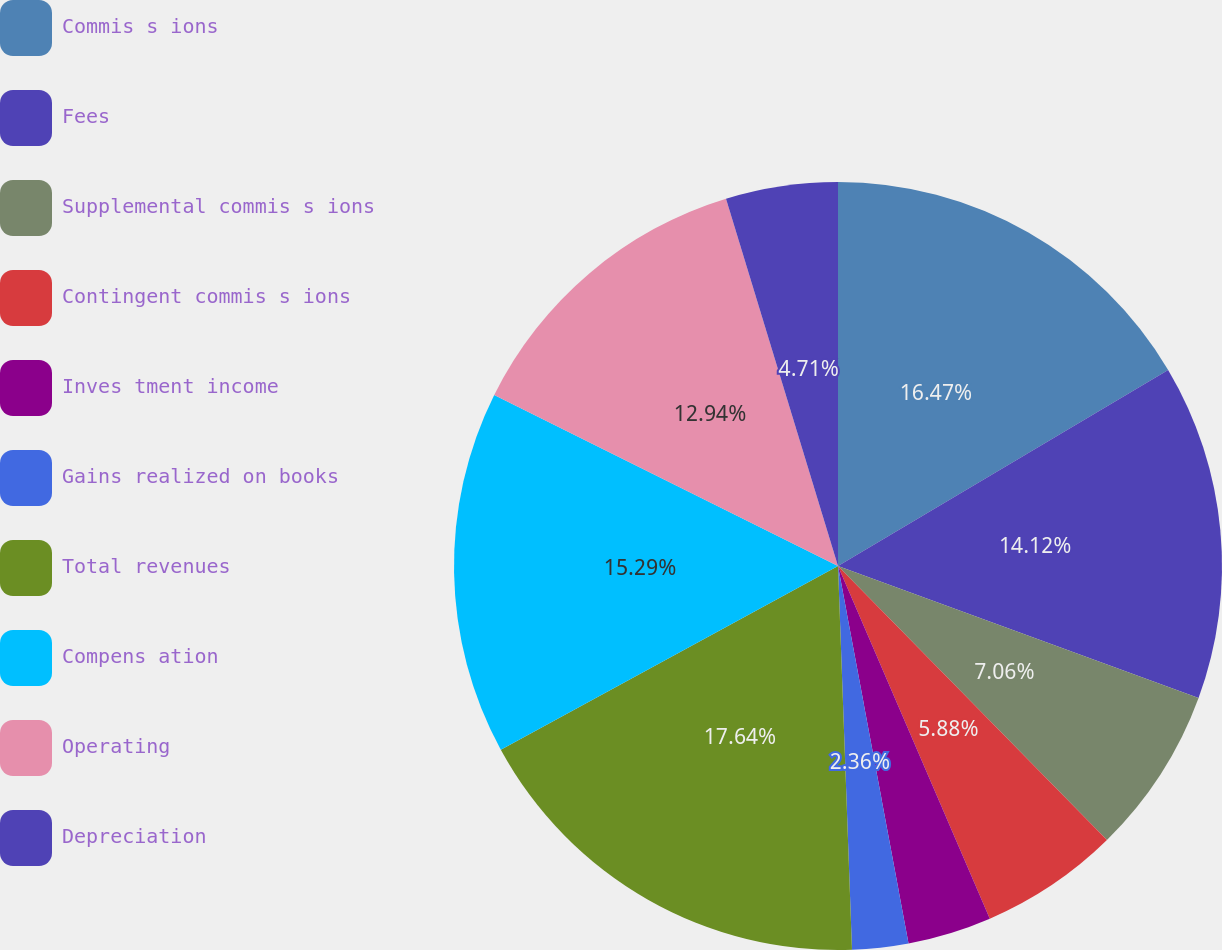Convert chart. <chart><loc_0><loc_0><loc_500><loc_500><pie_chart><fcel>Commis s ions<fcel>Fees<fcel>Supplemental commis s ions<fcel>Contingent commis s ions<fcel>Inves tment income<fcel>Gains realized on books<fcel>Total revenues<fcel>Compens ation<fcel>Operating<fcel>Depreciation<nl><fcel>16.47%<fcel>14.12%<fcel>7.06%<fcel>5.88%<fcel>3.53%<fcel>2.36%<fcel>17.64%<fcel>15.29%<fcel>12.94%<fcel>4.71%<nl></chart> 